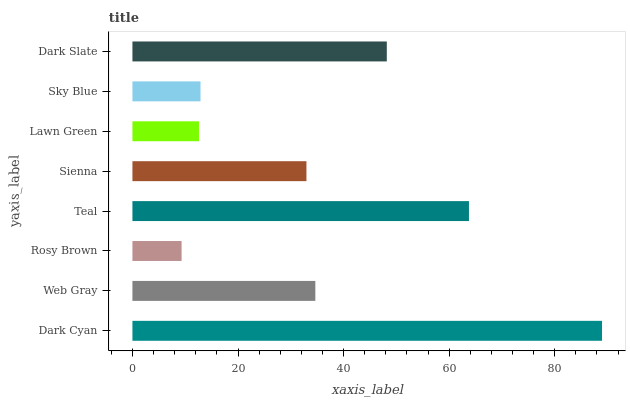Is Rosy Brown the minimum?
Answer yes or no. Yes. Is Dark Cyan the maximum?
Answer yes or no. Yes. Is Web Gray the minimum?
Answer yes or no. No. Is Web Gray the maximum?
Answer yes or no. No. Is Dark Cyan greater than Web Gray?
Answer yes or no. Yes. Is Web Gray less than Dark Cyan?
Answer yes or no. Yes. Is Web Gray greater than Dark Cyan?
Answer yes or no. No. Is Dark Cyan less than Web Gray?
Answer yes or no. No. Is Web Gray the high median?
Answer yes or no. Yes. Is Sienna the low median?
Answer yes or no. Yes. Is Dark Cyan the high median?
Answer yes or no. No. Is Teal the low median?
Answer yes or no. No. 